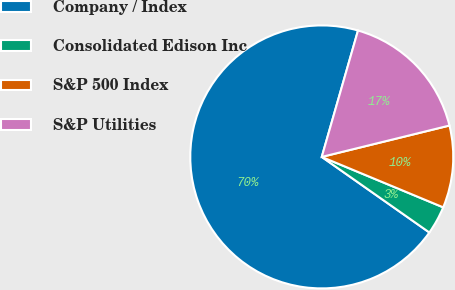Convert chart to OTSL. <chart><loc_0><loc_0><loc_500><loc_500><pie_chart><fcel>Company / Index<fcel>Consolidated Edison Inc<fcel>S&P 500 Index<fcel>S&P Utilities<nl><fcel>69.7%<fcel>3.48%<fcel>10.1%<fcel>16.72%<nl></chart> 